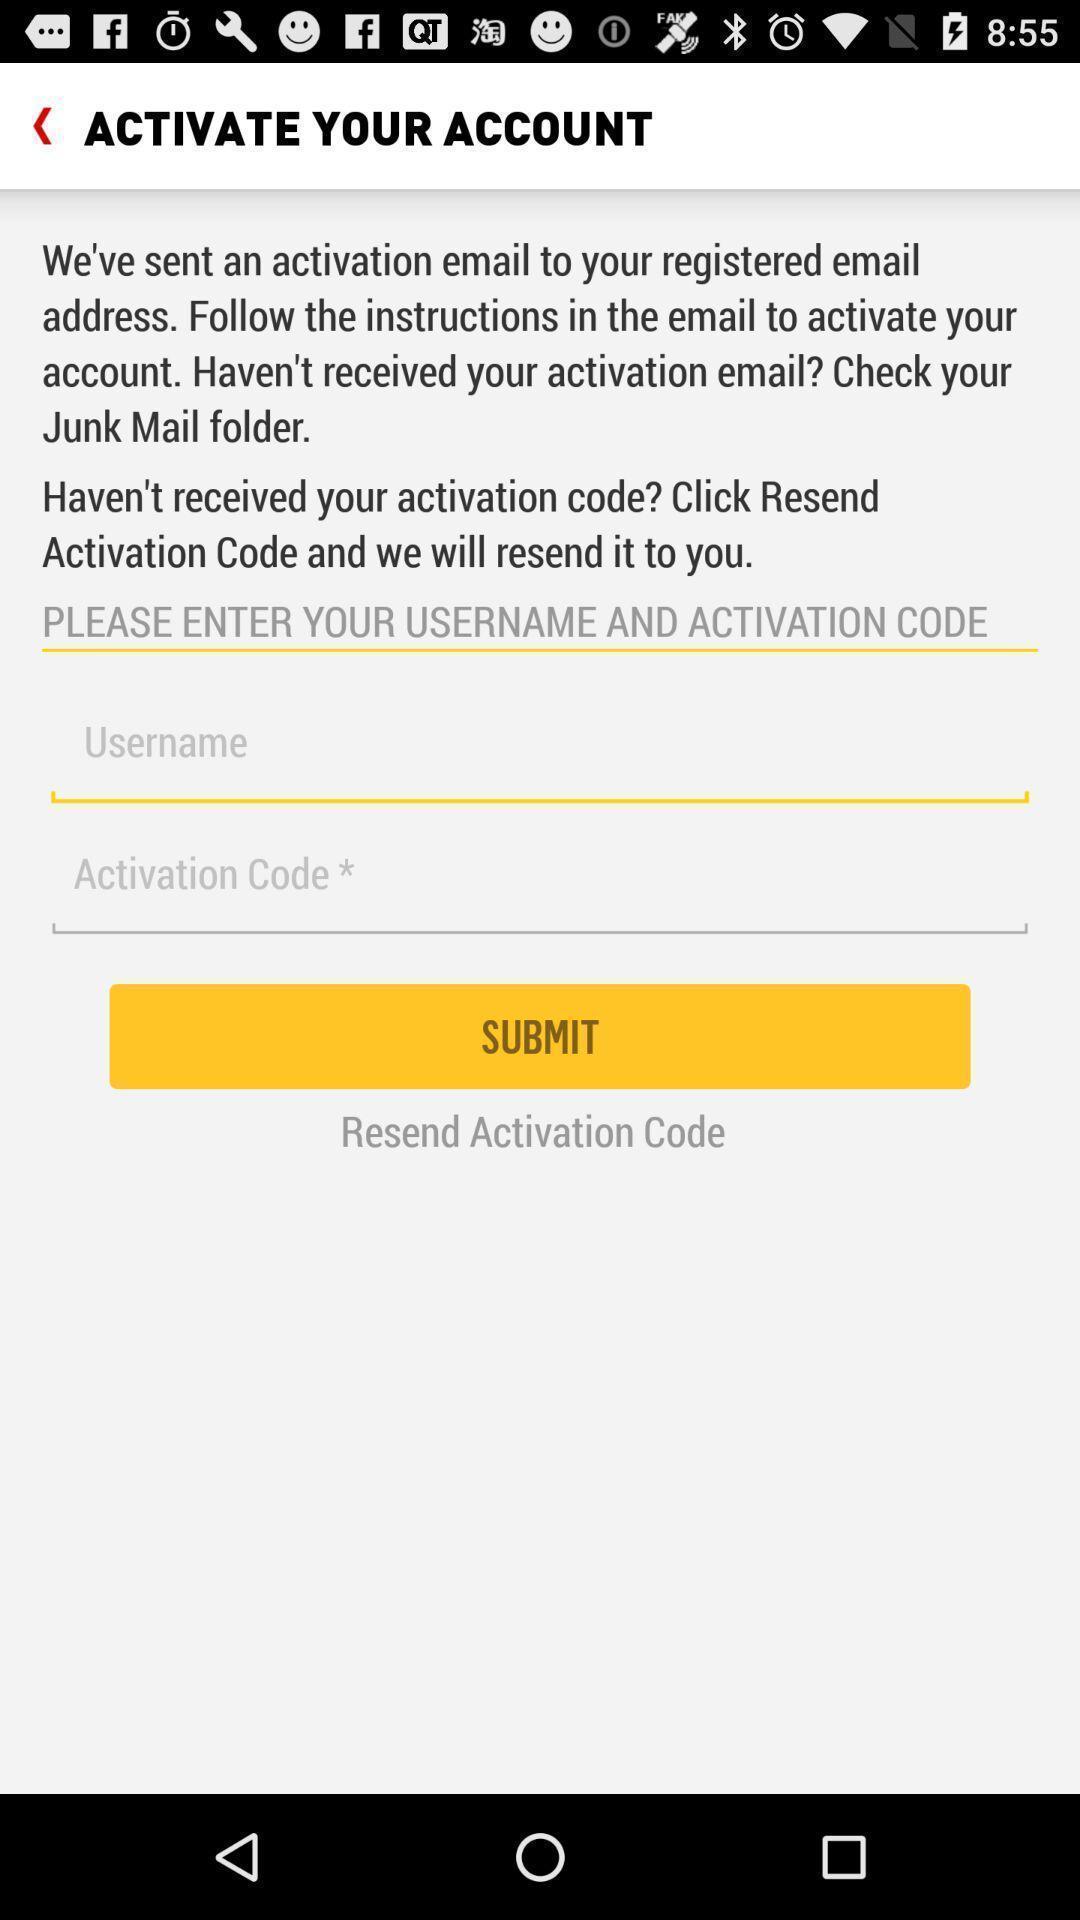Please provide a description for this image. Submit page for entering details for activation of an account. 